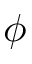Convert formula to latex. <formula><loc_0><loc_0><loc_500><loc_500>\phi</formula> 